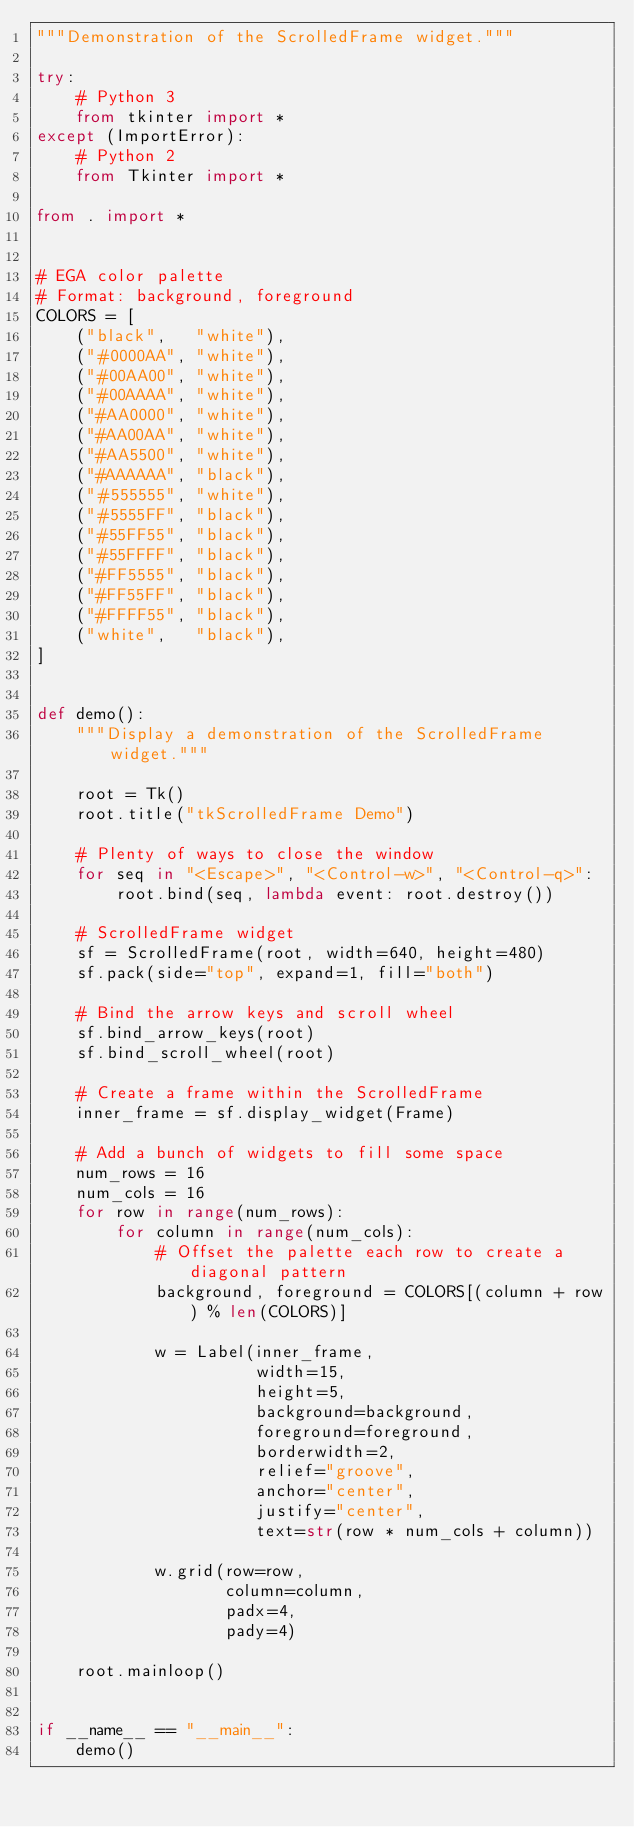Convert code to text. <code><loc_0><loc_0><loc_500><loc_500><_Python_>"""Demonstration of the ScrolledFrame widget."""

try:
    # Python 3
    from tkinter import *
except (ImportError):
    # Python 2
    from Tkinter import *

from . import *


# EGA color palette
# Format: background, foreground
COLORS = [
    ("black",   "white"),
    ("#0000AA", "white"),
    ("#00AA00", "white"),
    ("#00AAAA", "white"),
    ("#AA0000", "white"),
    ("#AA00AA", "white"),
    ("#AA5500", "white"),
    ("#AAAAAA", "black"),
    ("#555555", "white"),
    ("#5555FF", "black"),
    ("#55FF55", "black"),
    ("#55FFFF", "black"),
    ("#FF5555", "black"),
    ("#FF55FF", "black"),
    ("#FFFF55", "black"),
    ("white",   "black"),
]


def demo():
    """Display a demonstration of the ScrolledFrame widget."""

    root = Tk()
    root.title("tkScrolledFrame Demo")

    # Plenty of ways to close the window
    for seq in "<Escape>", "<Control-w>", "<Control-q>":
        root.bind(seq, lambda event: root.destroy())

    # ScrolledFrame widget
    sf = ScrolledFrame(root, width=640, height=480)
    sf.pack(side="top", expand=1, fill="both")

    # Bind the arrow keys and scroll wheel
    sf.bind_arrow_keys(root)
    sf.bind_scroll_wheel(root)

    # Create a frame within the ScrolledFrame
    inner_frame = sf.display_widget(Frame)

    # Add a bunch of widgets to fill some space
    num_rows = 16
    num_cols = 16
    for row in range(num_rows):
        for column in range(num_cols):
            # Offset the palette each row to create a diagonal pattern
            background, foreground = COLORS[(column + row) % len(COLORS)]

            w = Label(inner_frame,
                      width=15,
                      height=5,
                      background=background,
                      foreground=foreground,
                      borderwidth=2,
                      relief="groove",
                      anchor="center",
                      justify="center",
                      text=str(row * num_cols + column))

            w.grid(row=row,
                   column=column,
                   padx=4,
                   pady=4)

    root.mainloop()


if __name__ == "__main__":
    demo()
</code> 